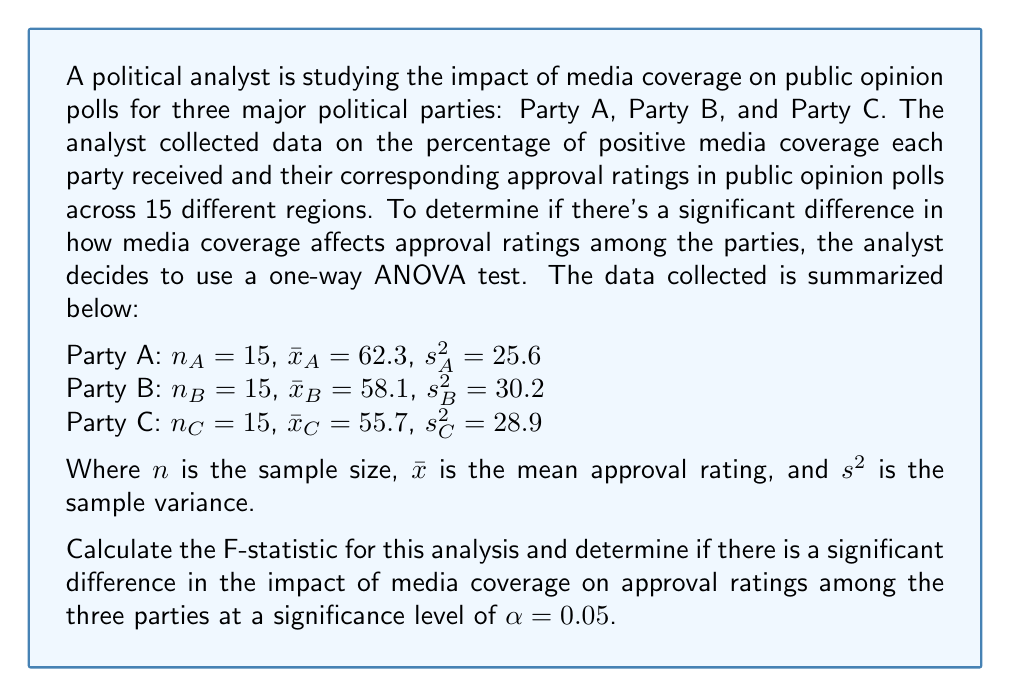Can you solve this math problem? To solve this problem, we need to follow these steps:

1. Calculate the between-group sum of squares (SSB)
2. Calculate the within-group sum of squares (SSW)
3. Calculate the degrees of freedom for between-groups (dfB) and within-groups (dfW)
4. Calculate the mean square between-groups (MSB) and mean square within-groups (MSW)
5. Calculate the F-statistic
6. Compare the F-statistic to the critical F-value

Step 1: Calculate SSB
First, we need to find the grand mean:
$$\bar{x} = \frac{62.3 + 58.1 + 55.7}{3} = 58.7$$

Now, we can calculate SSB:
$$SSB = \sum_{i=1}^{k} n_i(\bar{x}_i - \bar{x})^2$$
$$SSB = 15(62.3 - 58.7)^2 + 15(58.1 - 58.7)^2 + 15(55.7 - 58.7)^2$$
$$SSB = 15(3.6^2) + 15(-0.6^2) + 15(-3^2)$$
$$SSB = 194.4 + 5.4 + 135 = 334.8$$

Step 2: Calculate SSW
$$SSW = \sum_{i=1}^{k} (n_i - 1)s_i^2$$
$$SSW = 14(25.6) + 14(30.2) + 14(28.9)$$
$$SSW = 358.4 + 422.8 + 404.6 = 1185.8$$

Step 3: Calculate degrees of freedom
dfB = k - 1 = 3 - 1 = 2
dfW = N - k = 45 - 3 = 42

Step 4: Calculate MSB and MSW
$$MSB = \frac{SSB}{dfB} = \frac{334.8}{2} = 167.4$$
$$MSW = \frac{SSW}{dfW} = \frac{1185.8}{42} = 28.2333$$

Step 5: Calculate F-statistic
$$F = \frac{MSB}{MSW} = \frac{167.4}{28.2333} = 5.9292$$

Step 6: Compare F-statistic to critical F-value
For $\alpha = 0.05$, dfB = 2, and dfW = 42, the critical F-value is approximately 3.22 (from F-distribution table).

Since our calculated F-statistic (5.9292) is greater than the critical F-value (3.22), we reject the null hypothesis.
Answer: The F-statistic is 5.9292. Since this value is greater than the critical F-value of 3.22 at $\alpha = 0.05$, we conclude that there is a significant difference in the impact of media coverage on approval ratings among the three political parties. 